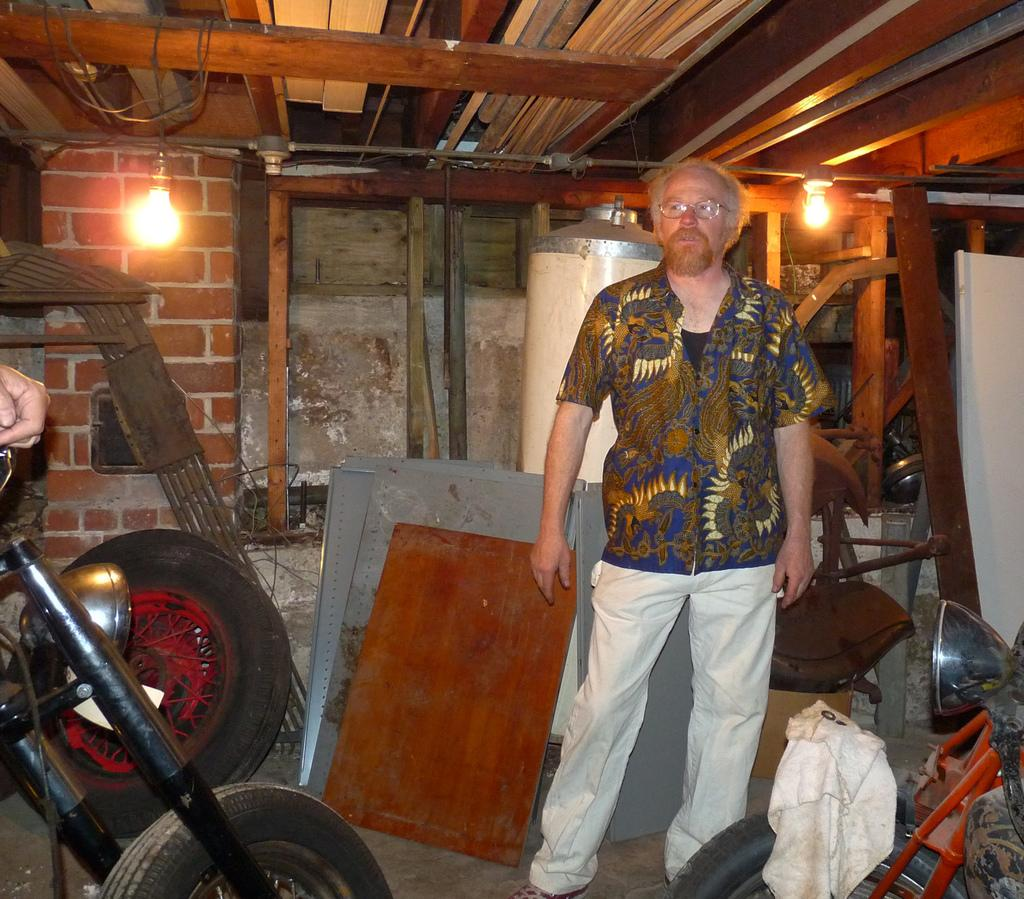What can be found in the room that might be used for repairs or assembly? There are spare parts in the room. Can you describe the person in the room? There is a person standing in the room. How many lights are visible in the room? There are two lights visible in the room. What type of expansion is taking place in the room? There is no indication of any expansion happening in the room. Is there an oven present in the room? There is no mention of an oven in the provided facts, so it cannot be determined if one is present in the room. 